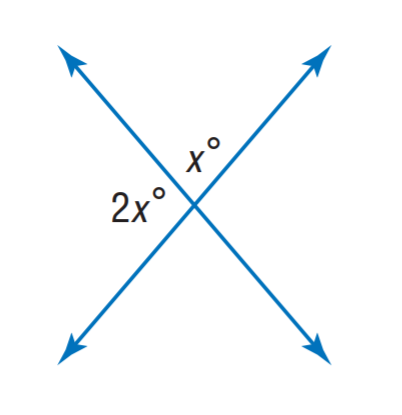Question: Find x.
Choices:
A. 40
B. 60
C. 80
D. 100
Answer with the letter. Answer: B 